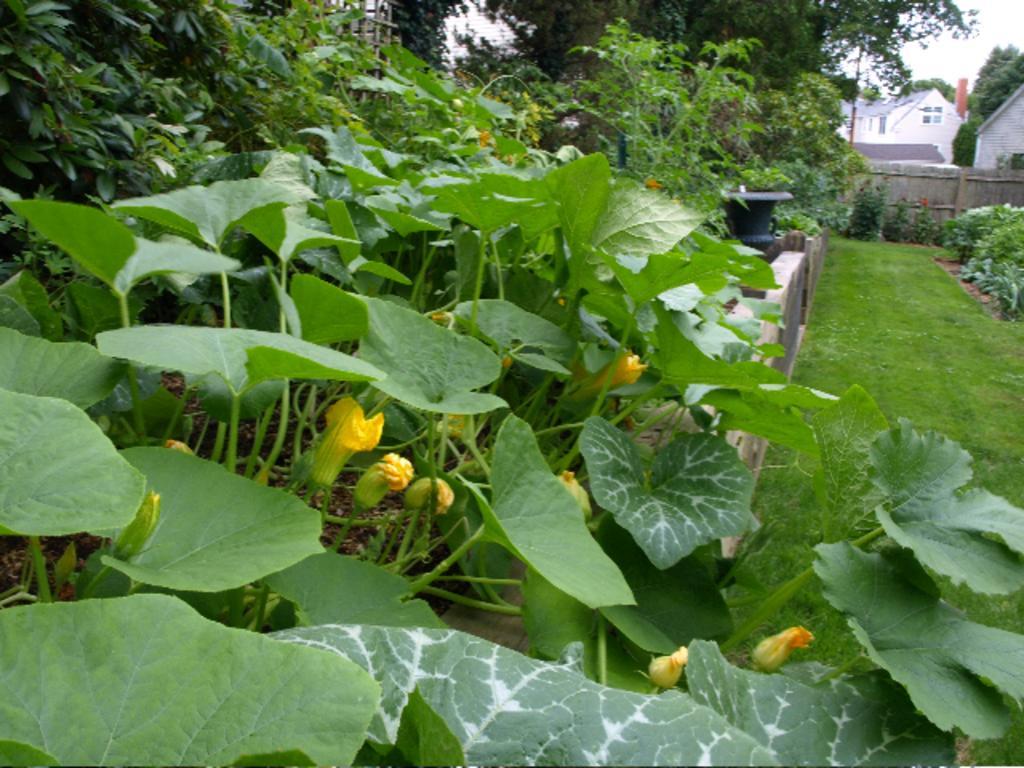In one or two sentences, can you explain what this image depicts? In this image there are few creeper plants having few leaves and flowers. Behind there is a fence on the grassland. Behind the fence there is a pot. Right side there is a fence. Behind there are few buildings. Background there are few plants and trees. Right top there is sky. 